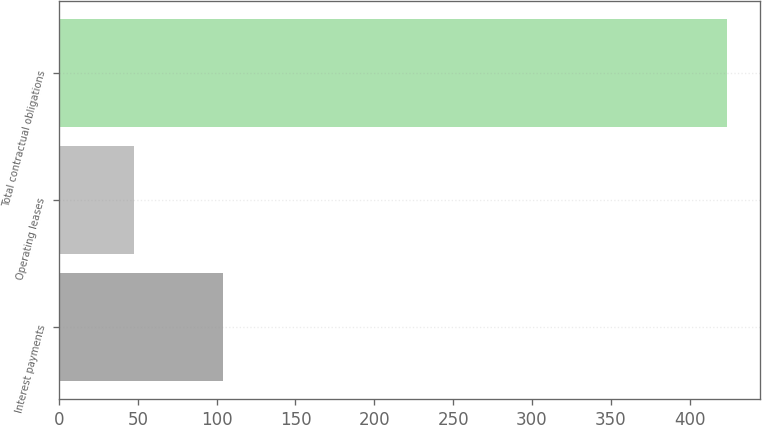Convert chart to OTSL. <chart><loc_0><loc_0><loc_500><loc_500><bar_chart><fcel>Interest payments<fcel>Operating leases<fcel>Total contractual obligations<nl><fcel>103.8<fcel>47.6<fcel>423.5<nl></chart> 